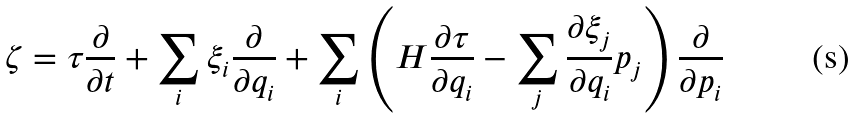Convert formula to latex. <formula><loc_0><loc_0><loc_500><loc_500>\zeta = \tau \frac { \partial } { \partial t } + \sum _ { i } \xi _ { i } \frac { \partial } { \partial q _ { i } } + \sum _ { i } \left ( H \frac { \partial \tau } { \partial q _ { i } } - \sum _ { j } \frac { \partial \xi _ { j } } { \partial q _ { i } } p _ { j } \right ) \frac { \partial } { \partial p _ { i } }</formula> 